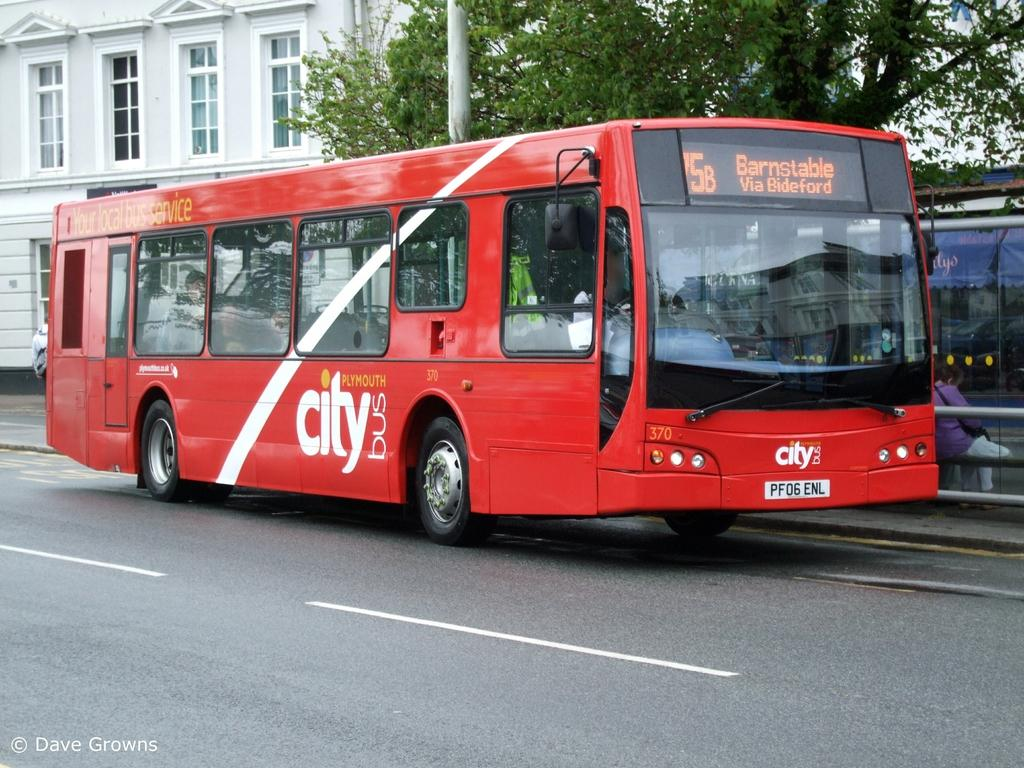<image>
Share a concise interpretation of the image provided. A red Plymouth City bus is travelling on the road. 